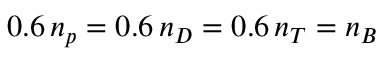<formula> <loc_0><loc_0><loc_500><loc_500>0 . 6 \, n _ { p } = 0 . 6 \, n _ { D } = 0 . 6 \, n _ { T } = n _ { B }</formula> 